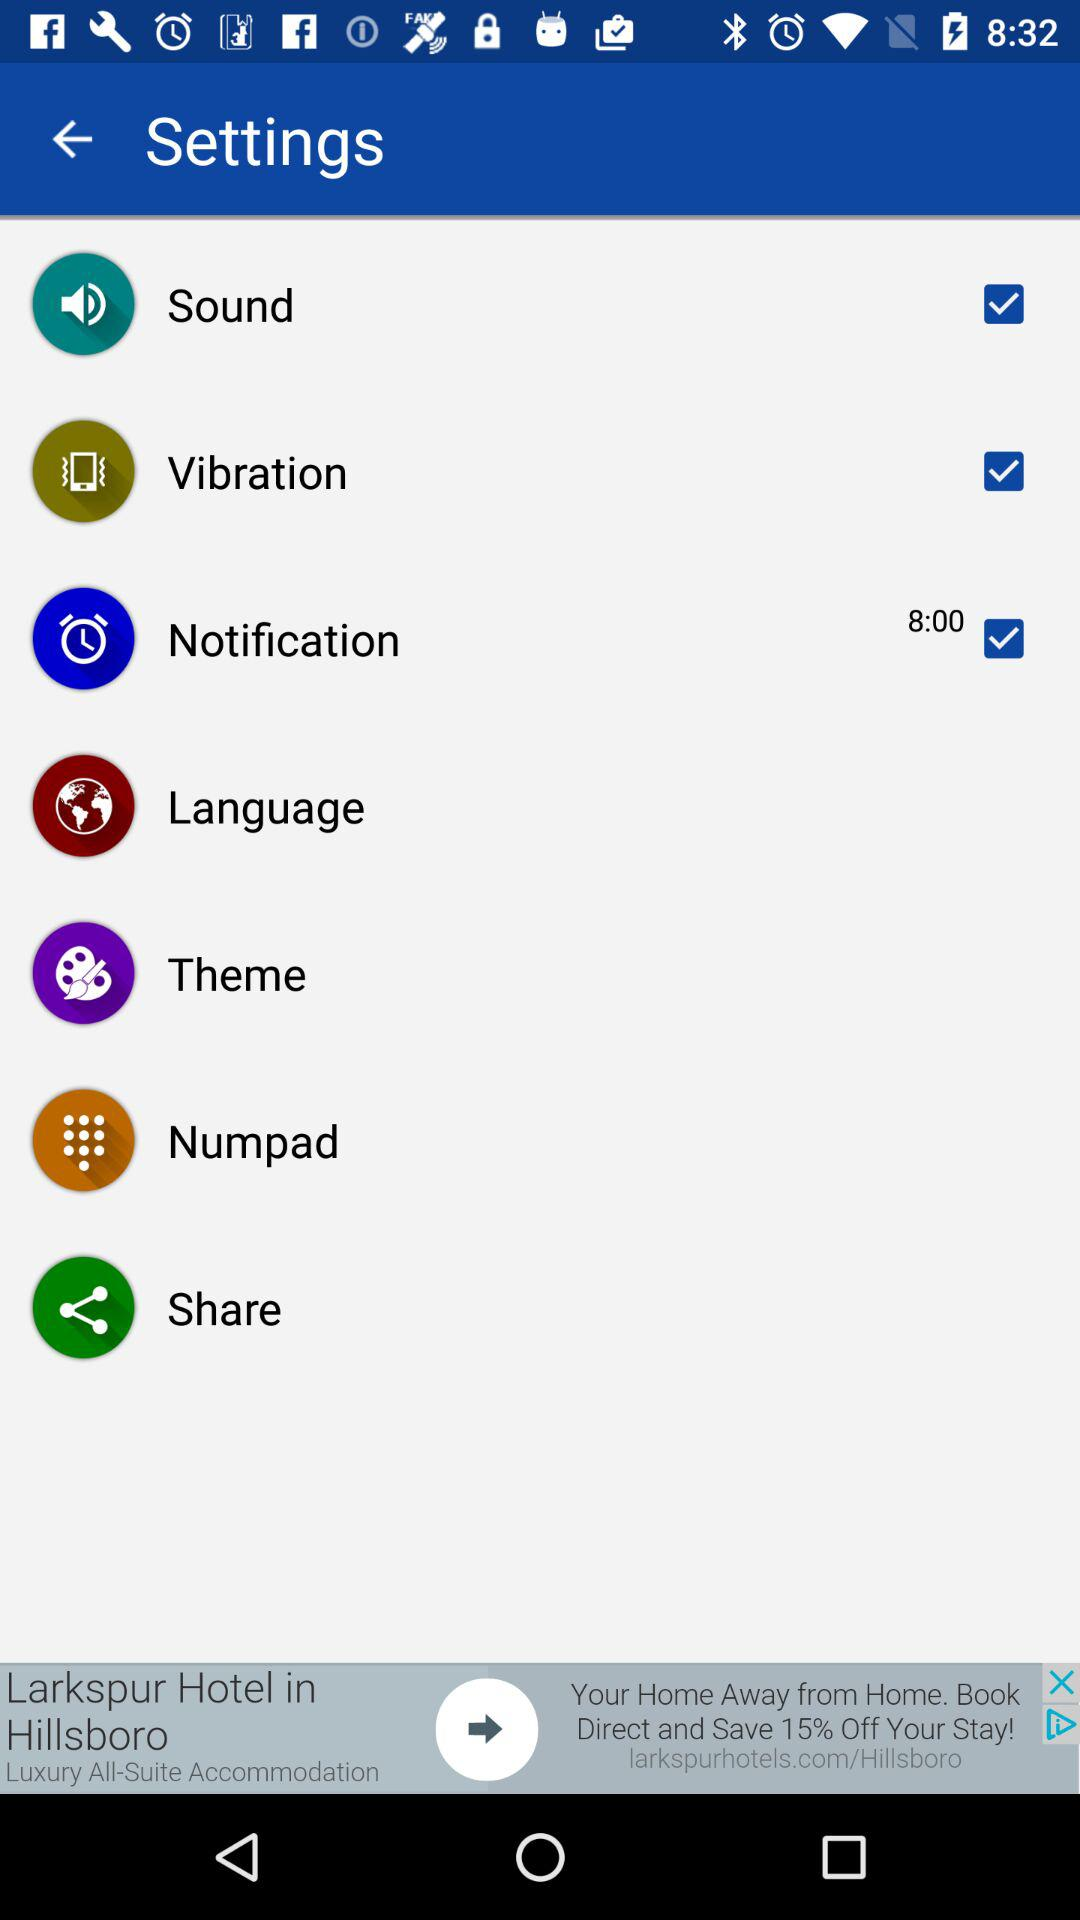Which setting options are selected? The options are sound, vibration and notification. 